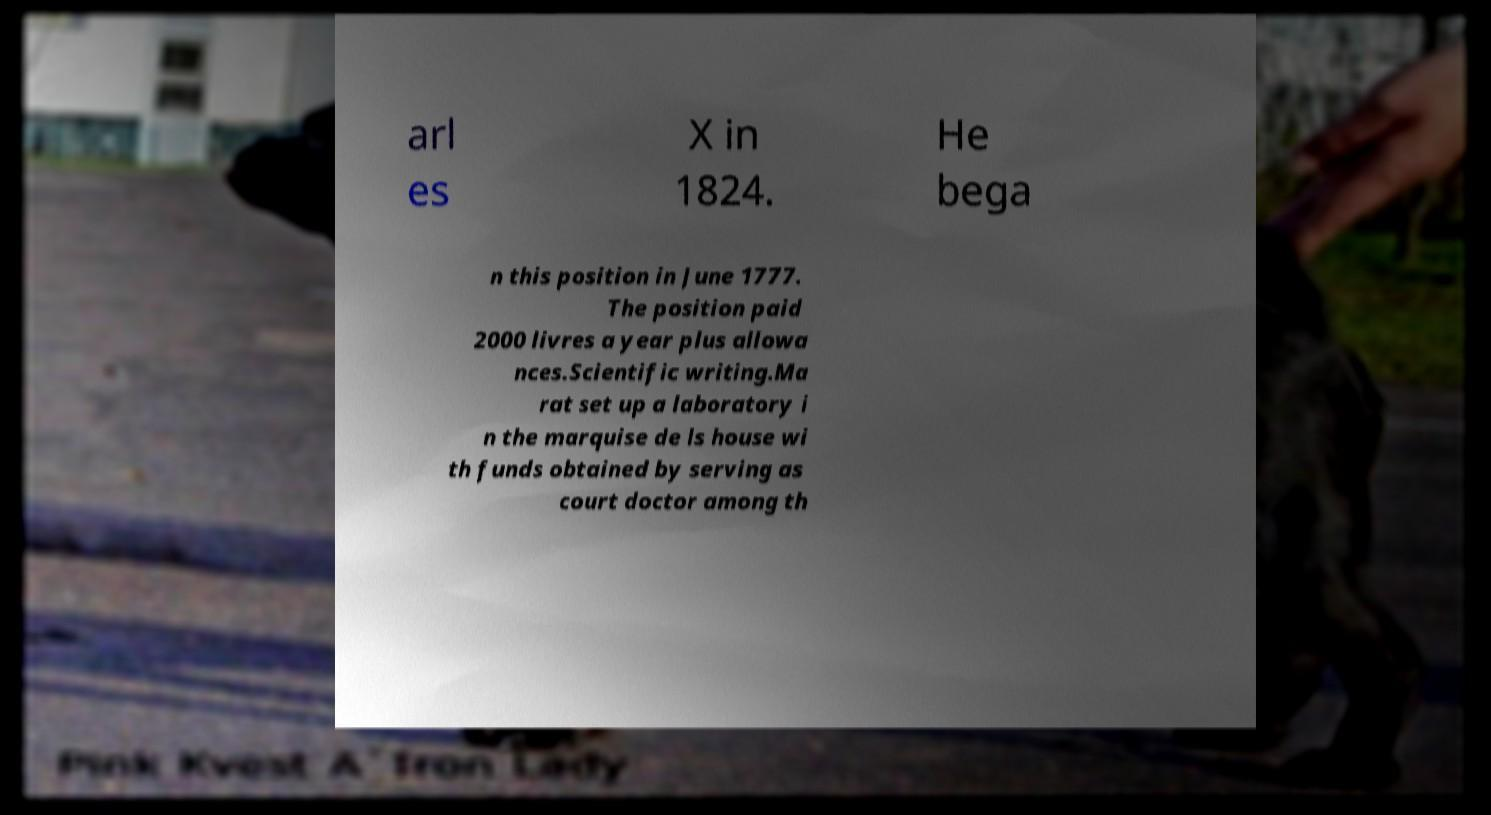What messages or text are displayed in this image? I need them in a readable, typed format. arl es X in 1824. He bega n this position in June 1777. The position paid 2000 livres a year plus allowa nces.Scientific writing.Ma rat set up a laboratory i n the marquise de ls house wi th funds obtained by serving as court doctor among th 